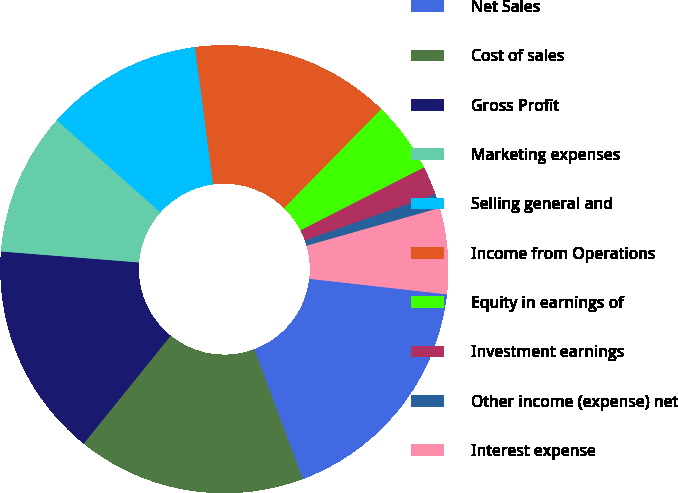<chart> <loc_0><loc_0><loc_500><loc_500><pie_chart><fcel>Net Sales<fcel>Cost of sales<fcel>Gross Profit<fcel>Marketing expenses<fcel>Selling general and<fcel>Income from Operations<fcel>Equity in earnings of<fcel>Investment earnings<fcel>Other income (expense) net<fcel>Interest expense<nl><fcel>17.52%<fcel>16.49%<fcel>15.46%<fcel>10.31%<fcel>11.34%<fcel>14.43%<fcel>5.16%<fcel>2.06%<fcel>1.03%<fcel>6.19%<nl></chart> 